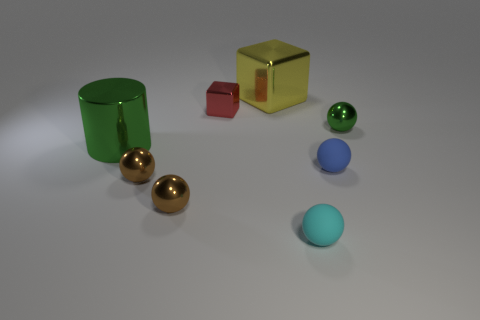The tiny thing that is both behind the cylinder and to the left of the big metallic block has what shape?
Provide a succinct answer. Cube. What number of objects are blocks behind the red metal object or spheres that are on the left side of the tiny blue matte object?
Offer a terse response. 4. Are there an equal number of green spheres that are on the right side of the small green ball and tiny brown spheres behind the large metal block?
Make the answer very short. Yes. There is a big metal object in front of the ball behind the big cylinder; what shape is it?
Provide a succinct answer. Cylinder. Is there another small shiny thing that has the same shape as the red metal object?
Provide a succinct answer. No. How many tiny cyan matte balls are there?
Your answer should be compact. 1. Do the green object to the right of the tiny metal block and the big green object have the same material?
Your response must be concise. Yes. Are there any blue spheres that have the same size as the green cylinder?
Provide a short and direct response. No. There is a blue thing; does it have the same shape as the large shiny thing that is left of the yellow metallic block?
Your response must be concise. No. There is a small object that is behind the green metal thing that is to the right of the cyan ball; is there a small red block behind it?
Make the answer very short. No. 